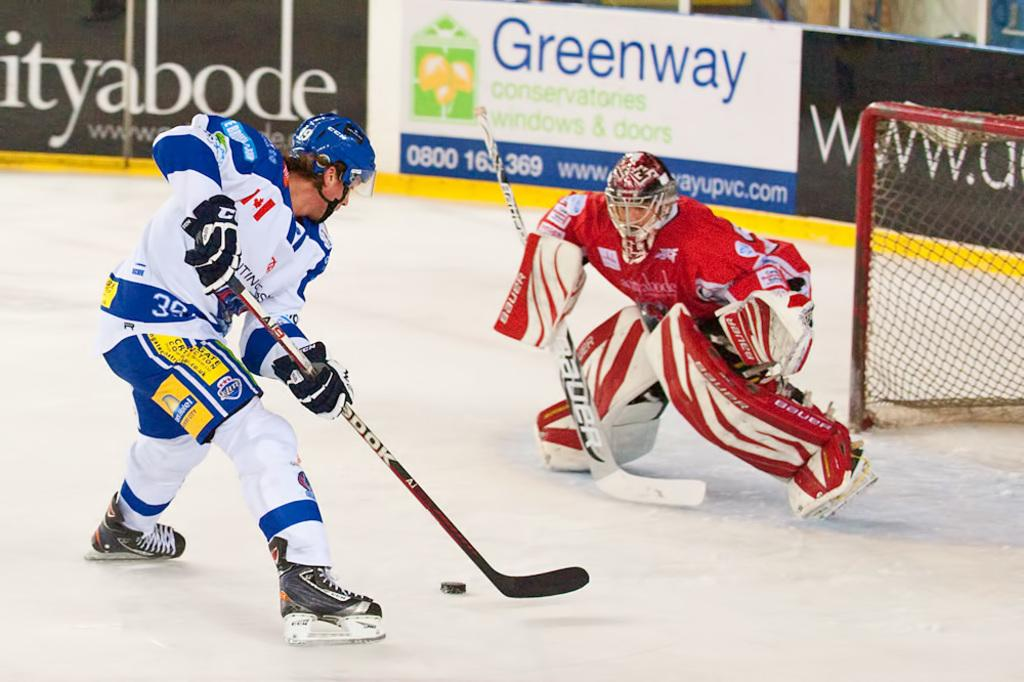<image>
Describe the image concisely. a couple players playing with a Greenway sign behind them 